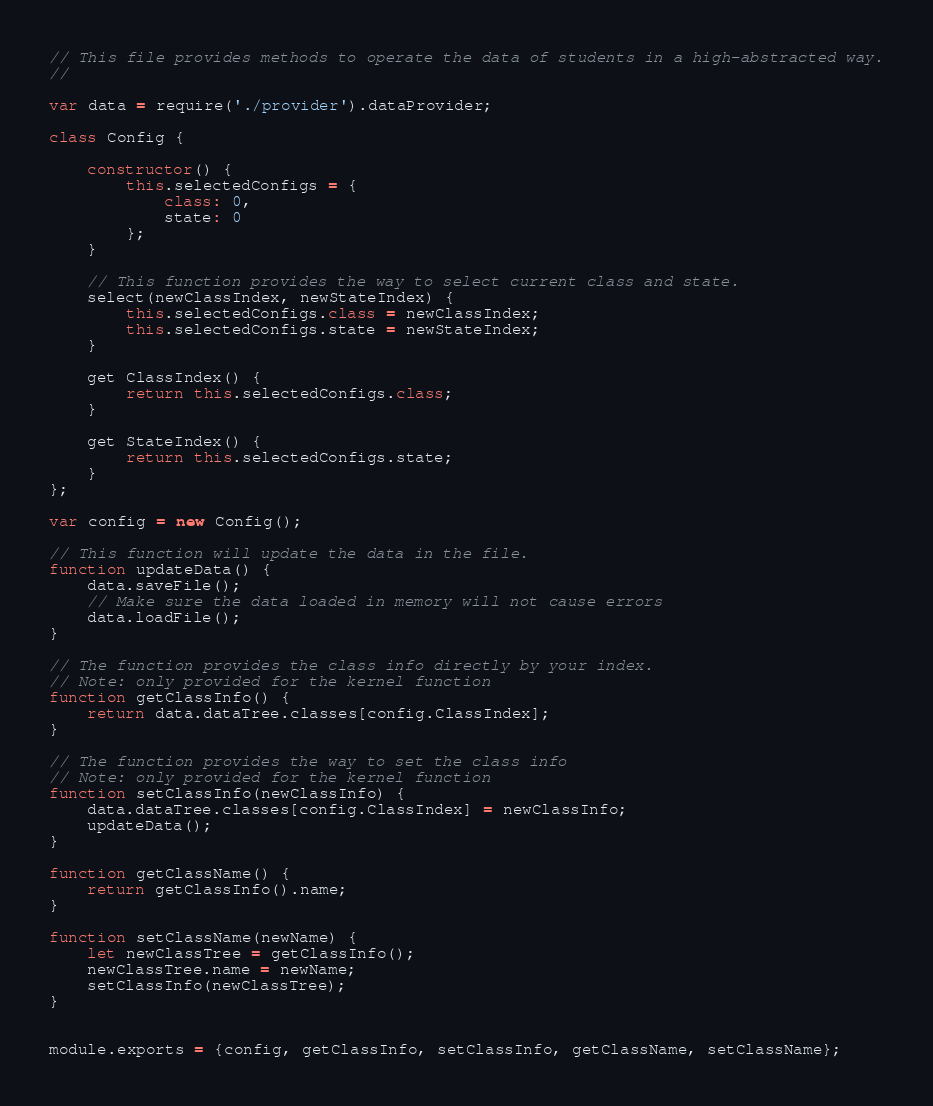Convert code to text. <code><loc_0><loc_0><loc_500><loc_500><_JavaScript_>// This file provides methods to operate the data of students in a high-abstracted way.
//

var data = require('./provider').dataProvider;

class Config {

    constructor() {
        this.selectedConfigs = {
            class: 0,
            state: 0
        };
    }

    // This function provides the way to select current class and state.
    select(newClassIndex, newStateIndex) {
        this.selectedConfigs.class = newClassIndex;
        this.selectedConfigs.state = newStateIndex;
    }

    get ClassIndex() {
        return this.selectedConfigs.class;
    }

    get StateIndex() {
        return this.selectedConfigs.state;
    }
};

var config = new Config();

// This function will update the data in the file. 
function updateData() {
    data.saveFile();
    // Make sure the data loaded in memory will not cause errors
    data.loadFile();
}

// The function provides the class info directly by your index.
// Note: only provided for the kernel function
function getClassInfo() {
    return data.dataTree.classes[config.ClassIndex];
}

// The function provides the way to set the class info
// Note: only provided for the kernel function
function setClassInfo(newClassInfo) {
    data.dataTree.classes[config.ClassIndex] = newClassInfo;
    updateData();
}

function getClassName() {
    return getClassInfo().name;
}

function setClassName(newName) {
    let newClassTree = getClassInfo();
    newClassTree.name = newName;
    setClassInfo(newClassTree);
}


module.exports = {config, getClassInfo, setClassInfo, getClassName, setClassName};</code> 